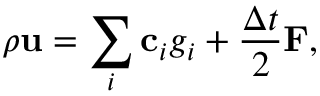<formula> <loc_0><loc_0><loc_500><loc_500>\rho u = \sum _ { i } c _ { i } g _ { i } + \frac { \Delta t } { 2 } F ,</formula> 